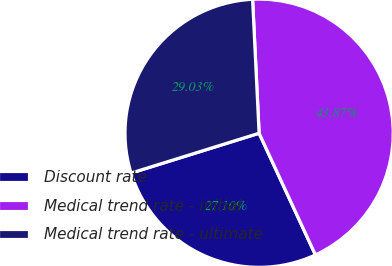Convert chart. <chart><loc_0><loc_0><loc_500><loc_500><pie_chart><fcel>Discount rate<fcel>Medical trend rate - initial<fcel>Medical trend rate - ultimate<nl><fcel>27.1%<fcel>43.87%<fcel>29.03%<nl></chart> 